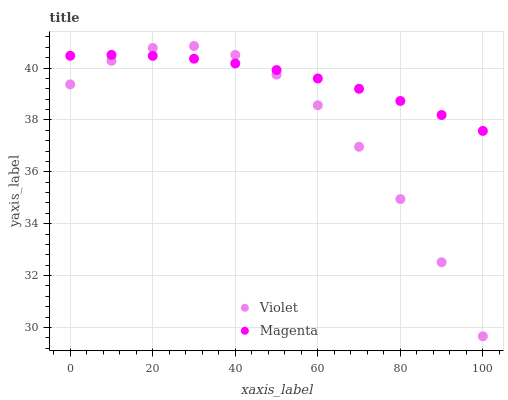Does Violet have the minimum area under the curve?
Answer yes or no. Yes. Does Magenta have the maximum area under the curve?
Answer yes or no. Yes. Does Violet have the maximum area under the curve?
Answer yes or no. No. Is Magenta the smoothest?
Answer yes or no. Yes. Is Violet the roughest?
Answer yes or no. Yes. Is Violet the smoothest?
Answer yes or no. No. Does Violet have the lowest value?
Answer yes or no. Yes. Does Violet have the highest value?
Answer yes or no. Yes. Does Violet intersect Magenta?
Answer yes or no. Yes. Is Violet less than Magenta?
Answer yes or no. No. Is Violet greater than Magenta?
Answer yes or no. No. 